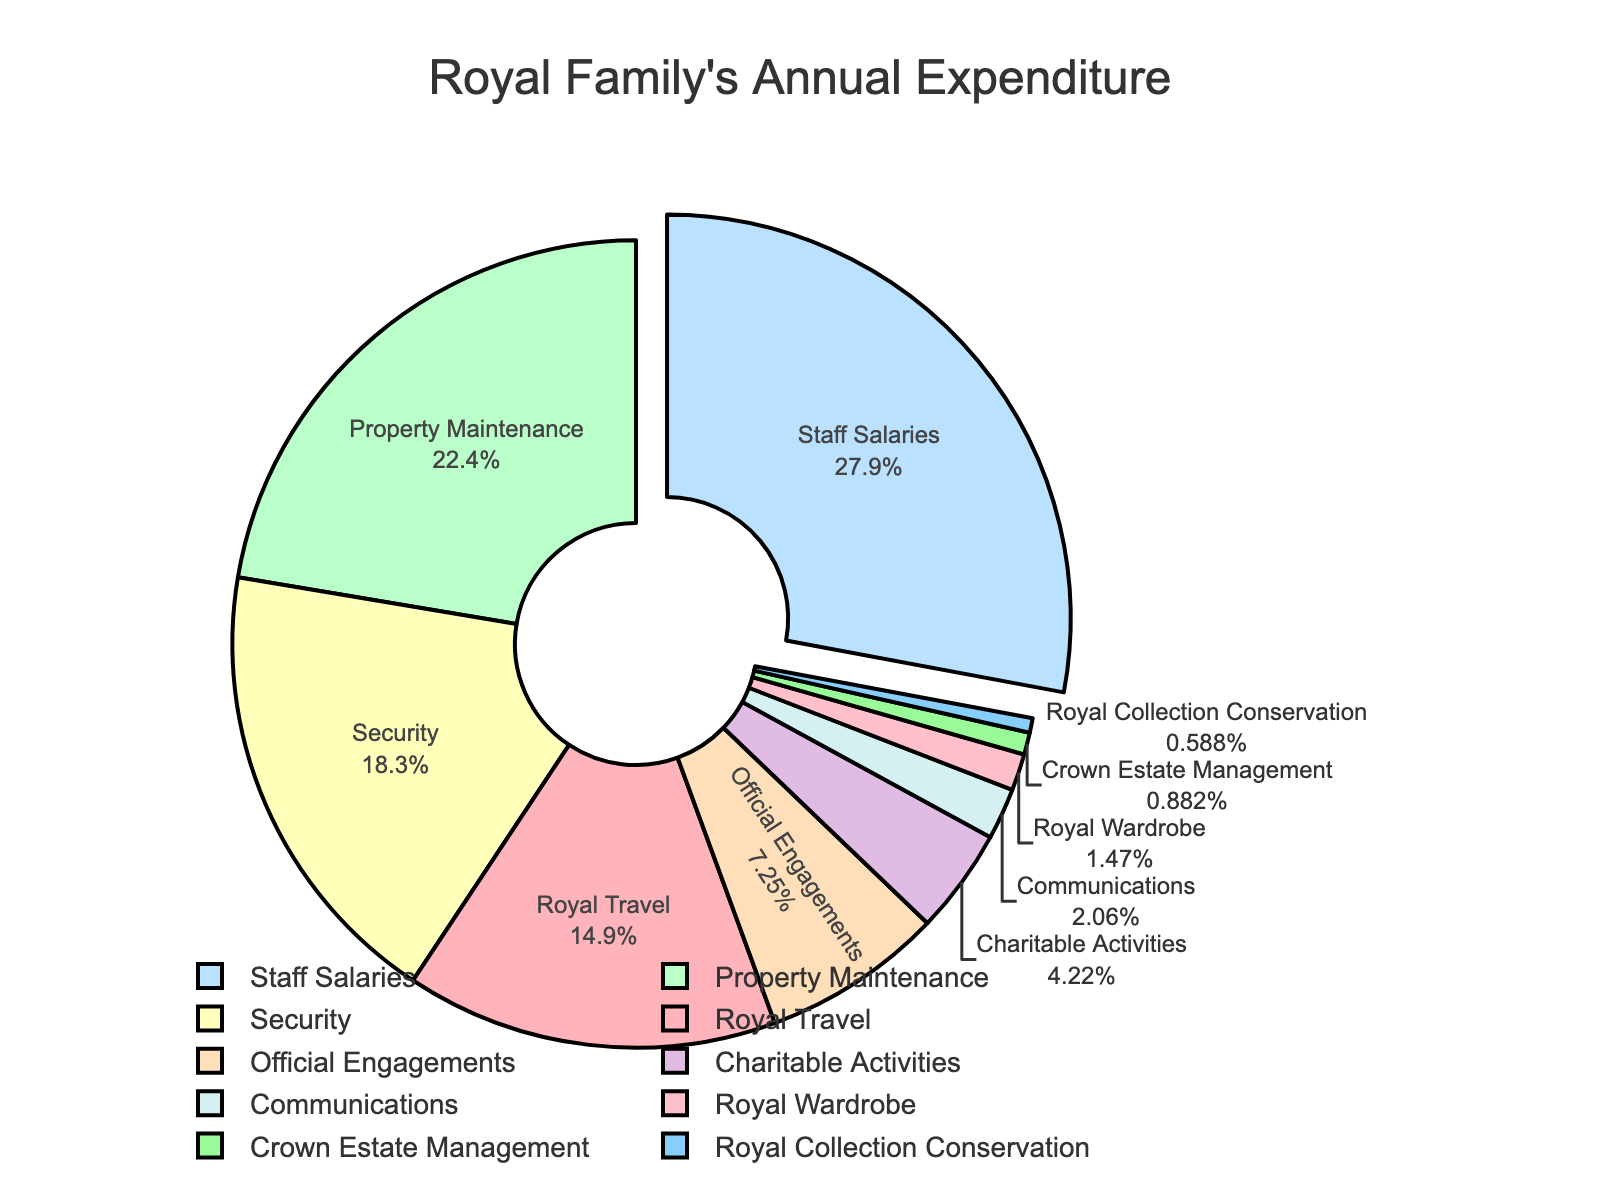Which category has the largest allocation percentage? Look at the segment that is slightly pulled out from the rest. This segment represents the category with the largest percentage.
Answer: Staff Salaries Which category has the smallest allocation percentage? Identify the smallest segment of the pie chart. This segment represents the category with the smallest percentage.
Answer: Royal Collection Conservation What is the combined percentage for Royal Travel and Security? Add the percentages for Royal Travel (15.2%) and Security (18.7%). 15.2% + 18.7% = 33.9%.
Answer: 33.9% How much more is spent on Staff Salaries compared to Property Maintenance? Subtract the percentage for Property Maintenance (22.8%) from Staff Salaries (28.5%). 28.5% - 22.8% = 5.7%.
Answer: 5.7% What is the percentage difference between the highest and lowest allocated categories? Identify the highest allocated category (Staff Salaries at 28.5%) and the lowest (Royal Collection Conservation at 0.6%), then subtract the smallest from the largest. 28.5% - 0.6% = 27.9%.
Answer: 27.9% Which three categories have allocations closest to 20%? Identify the segments closest to 20%. These are Property Maintenance (22.8%), Security (18.7%), and Royal Travel (15.2%). Clearly, Property Maintenance and Security are closest to 20%.
Answer: Property Maintenance and Security What is the total allocation percentage for all categories related to external engagements and activities? Add the percentages for Official Engagements (7.4%), Charitable Activities (4.3%), and Communications (2.1%). 7.4% + 4.3% + 2.1% = 13.8%.
Answer: 13.8% If we group Charitable Activities, Communications, Royal Wardrobe, Crown Estate Management, and Royal Collection Conservation, what is the total percentage? Add the percentages for these five categories: Charitable Activities (4.3%), Communications (2.1%), Royal Wardrobe (1.5%), Crown Estate Management (0.9%), and Royal Collection Conservation (0.6%). 4.3% + 2.1% + 1.5% + 0.9% + 0.6% = 9.4%.
Answer: 9.4% Which categories have an allocation percentage below 5%? Identify the segments with less than 5% allocation. These are Charitable Activities (4.3%), Communications (2.1%), Royal Wardrobe (1.5%), Crown Estate Management (0.9%), and Royal Collection Conservation (0.6%).
Answer: Charitable Activities, Communications, Royal Wardrobe, Crown Estate Management, Royal Collection Conservation 